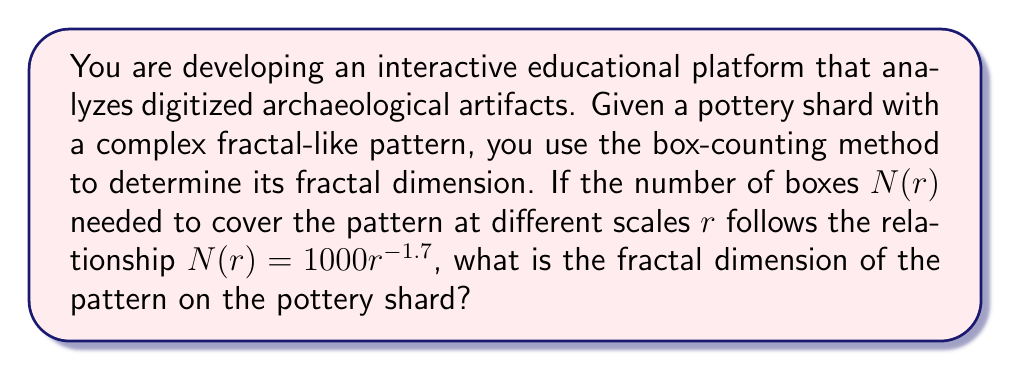Can you solve this math problem? To determine the fractal dimension using the box-counting method, we follow these steps:

1. The general relationship between $N(r)$ and $r$ in the box-counting method is:

   $$N(r) = kr^{-D}$$

   where $k$ is a constant, $r$ is the scale, and $D$ is the fractal dimension.

2. In our case, we are given:

   $$N(r) = 1000r^{-1.7}$$

3. Comparing this to the general form, we can see that:
   - $k = 1000$
   - The exponent $-1.7 = -D$

4. Therefore, the fractal dimension $D$ is the absolute value of the exponent:

   $$D = |-1.7| = 1.7$$

5. We can verify this by taking the logarithm of both sides of the equation:

   $$\log N(r) = \log(1000) - 1.7 \log(r)$$

   The slope of this log-log plot would be $-1.7$, confirming our result.
Answer: 1.7 